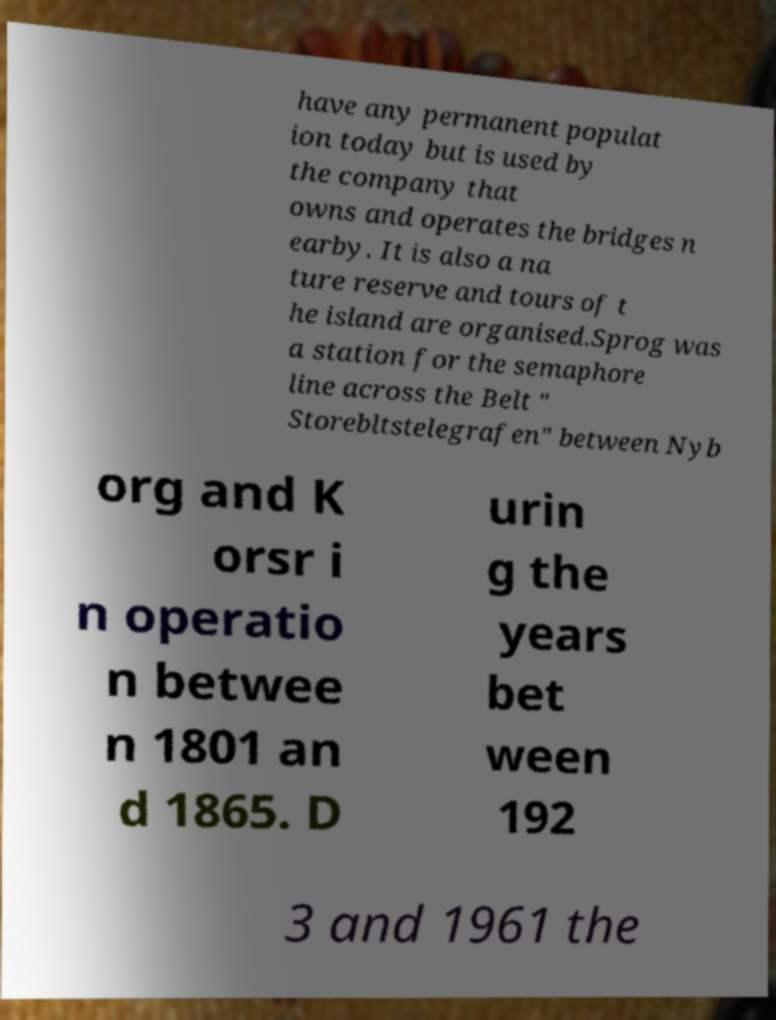Could you extract and type out the text from this image? have any permanent populat ion today but is used by the company that owns and operates the bridges n earby. It is also a na ture reserve and tours of t he island are organised.Sprog was a station for the semaphore line across the Belt " Storebltstelegrafen" between Nyb org and K orsr i n operatio n betwee n 1801 an d 1865. D urin g the years bet ween 192 3 and 1961 the 